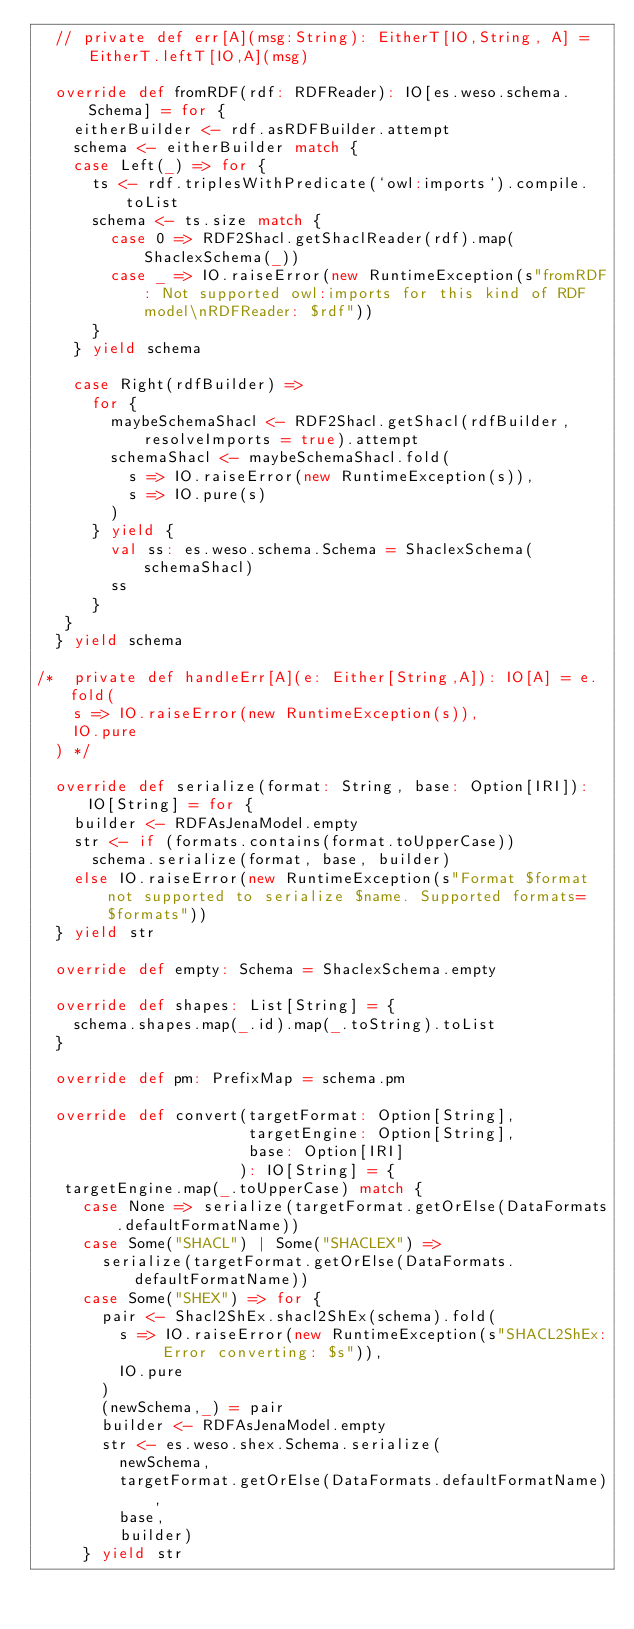<code> <loc_0><loc_0><loc_500><loc_500><_Scala_>  // private def err[A](msg:String): EitherT[IO,String, A] = EitherT.leftT[IO,A](msg)

  override def fromRDF(rdf: RDFReader): IO[es.weso.schema.Schema] = for {
    eitherBuilder <- rdf.asRDFBuilder.attempt
    schema <- eitherBuilder match {
    case Left(_) => for {
      ts <- rdf.triplesWithPredicate(`owl:imports`).compile.toList
      schema <- ts.size match {
        case 0 => RDF2Shacl.getShaclReader(rdf).map(ShaclexSchema(_))
        case _ => IO.raiseError(new RuntimeException(s"fromRDF: Not supported owl:imports for this kind of RDF model\nRDFReader: $rdf"))
      }
    } yield schema

    case Right(rdfBuilder) =>
      for {
        maybeSchemaShacl <- RDF2Shacl.getShacl(rdfBuilder, resolveImports = true).attempt
        schemaShacl <- maybeSchemaShacl.fold(
          s => IO.raiseError(new RuntimeException(s)),
          s => IO.pure(s)
        )
      } yield {
        val ss: es.weso.schema.Schema = ShaclexSchema(schemaShacl)
        ss
      }
   }
  } yield schema

/*  private def handleErr[A](e: Either[String,A]): IO[A] = e.fold(
    s => IO.raiseError(new RuntimeException(s)),
    IO.pure
  ) */

  override def serialize(format: String, base: Option[IRI]): IO[String] = for {
    builder <- RDFAsJenaModel.empty
    str <- if (formats.contains(format.toUpperCase))
      schema.serialize(format, base, builder)
    else IO.raiseError(new RuntimeException(s"Format $format not supported to serialize $name. Supported formats=$formats"))
  } yield str  

  override def empty: Schema = ShaclexSchema.empty

  override def shapes: List[String] = {
    schema.shapes.map(_.id).map(_.toString).toList
  }

  override def pm: PrefixMap = schema.pm

  override def convert(targetFormat: Option[String],
                       targetEngine: Option[String],
                       base: Option[IRI]
                      ): IO[String] = {
   targetEngine.map(_.toUpperCase) match {
     case None => serialize(targetFormat.getOrElse(DataFormats.defaultFormatName))
     case Some("SHACL") | Some("SHACLEX") =>
       serialize(targetFormat.getOrElse(DataFormats.defaultFormatName))
     case Some("SHEX") => for {
       pair <- Shacl2ShEx.shacl2ShEx(schema).fold(
         s => IO.raiseError(new RuntimeException(s"SHACL2ShEx: Error converting: $s")),
         IO.pure
       )
       (newSchema,_) = pair
       builder <- RDFAsJenaModel.empty
       str <- es.weso.shex.Schema.serialize(
         newSchema,
         targetFormat.getOrElse(DataFormats.defaultFormatName),
         base,
         builder)
     } yield str</code> 